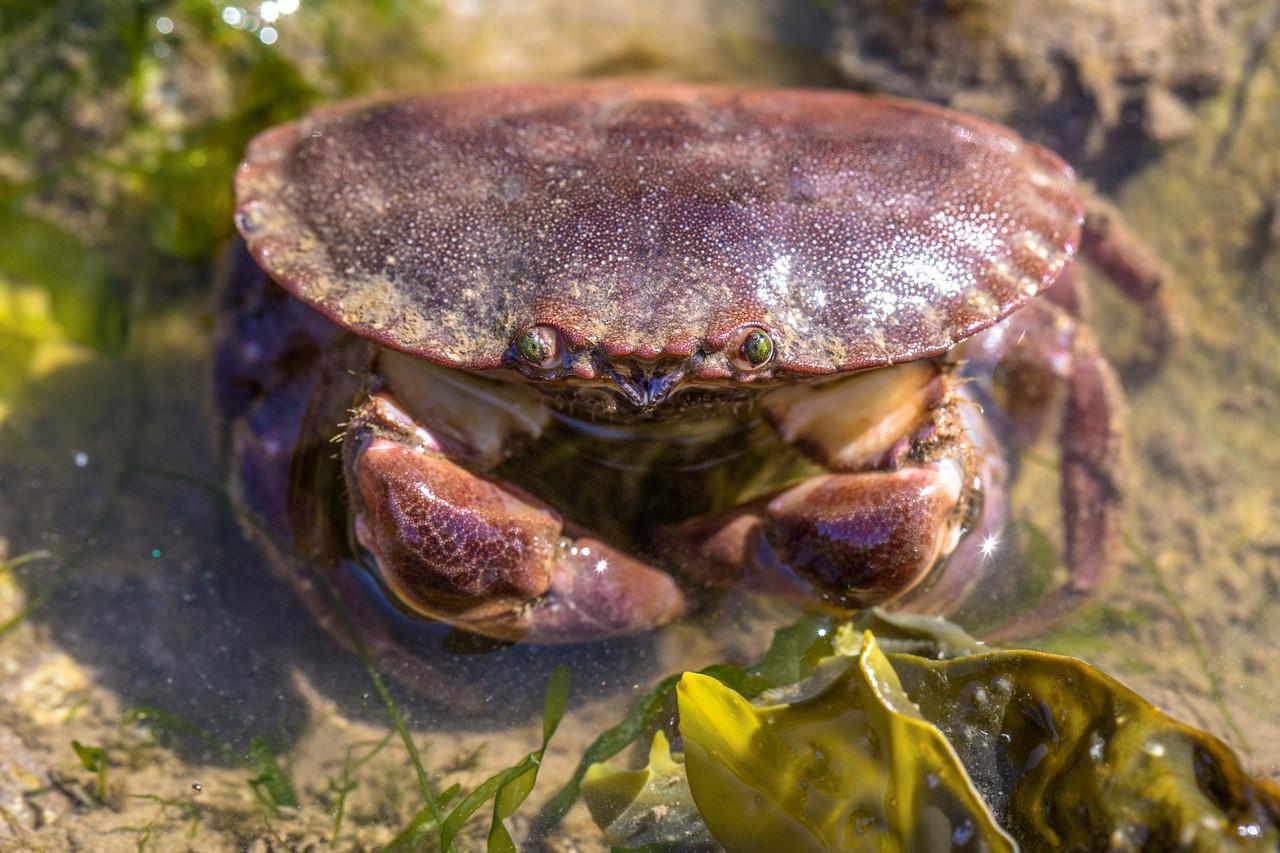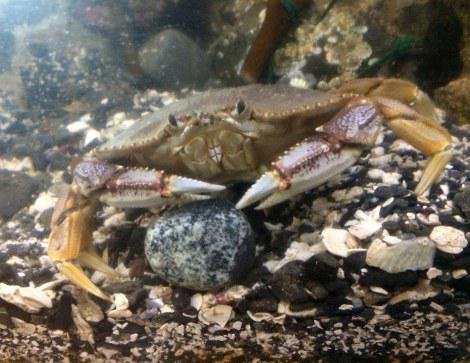The first image is the image on the left, the second image is the image on the right. Evaluate the accuracy of this statement regarding the images: "A single crab sits on a sediment surface in the image on the right.". Is it true? Answer yes or no. Yes. The first image is the image on the left, the second image is the image on the right. Analyze the images presented: Is the assertion "There are exactly two live crabs." valid? Answer yes or no. Yes. 